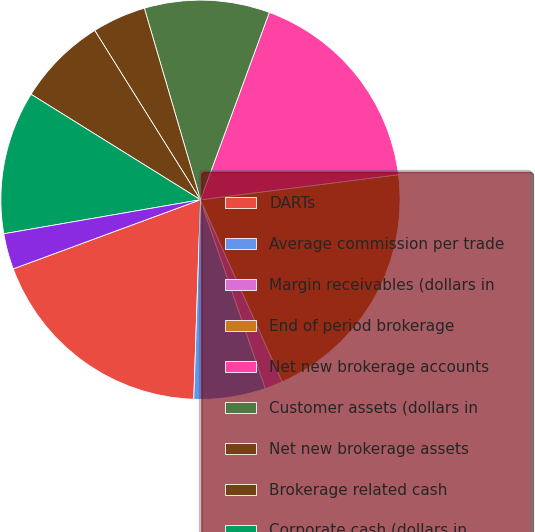Convert chart to OTSL. <chart><loc_0><loc_0><loc_500><loc_500><pie_chart><fcel>DARTs<fcel>Average commission per trade<fcel>Margin receivables (dollars in<fcel>End of period brokerage<fcel>Net new brokerage accounts<fcel>Customer assets (dollars in<fcel>Net new brokerage assets<fcel>Brokerage related cash<fcel>Corporate cash (dollars in<fcel>ETRADE Bank Tier 1 leverage<nl><fcel>18.84%<fcel>5.8%<fcel>1.45%<fcel>20.29%<fcel>17.39%<fcel>10.14%<fcel>4.35%<fcel>7.25%<fcel>11.59%<fcel>2.9%<nl></chart> 